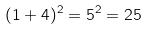<formula> <loc_0><loc_0><loc_500><loc_500>( 1 + 4 ) ^ { 2 } = 5 ^ { 2 } = 2 5</formula> 